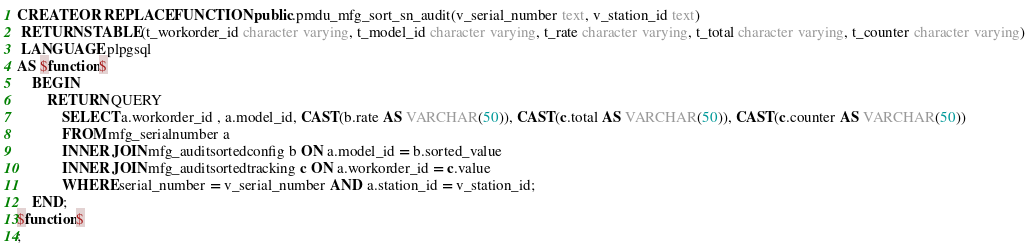Convert code to text. <code><loc_0><loc_0><loc_500><loc_500><_SQL_>CREATE OR REPLACE FUNCTION public.pmdu_mfg_sort_sn_audit(v_serial_number text, v_station_id text)
 RETURNS TABLE(t_workorder_id character varying, t_model_id character varying, t_rate character varying, t_total character varying, t_counter character varying)
 LANGUAGE plpgsql
AS $function$
	BEGIN
		RETURN QUERY
			SELECT a.workorder_id , a.model_id, CAST(b.rate AS VARCHAR(50)), CAST(c.total AS VARCHAR(50)), CAST(c.counter AS VARCHAR(50)) 
			FROM mfg_serialnumber a 
			INNER JOIN mfg_auditsortedconfig b ON a.model_id = b.sorted_value
			INNER JOIN mfg_auditsortedtracking c ON a.workorder_id = c.value
			WHERE serial_number = v_serial_number AND a.station_id = v_station_id;
	END;
$function$
;
</code> 